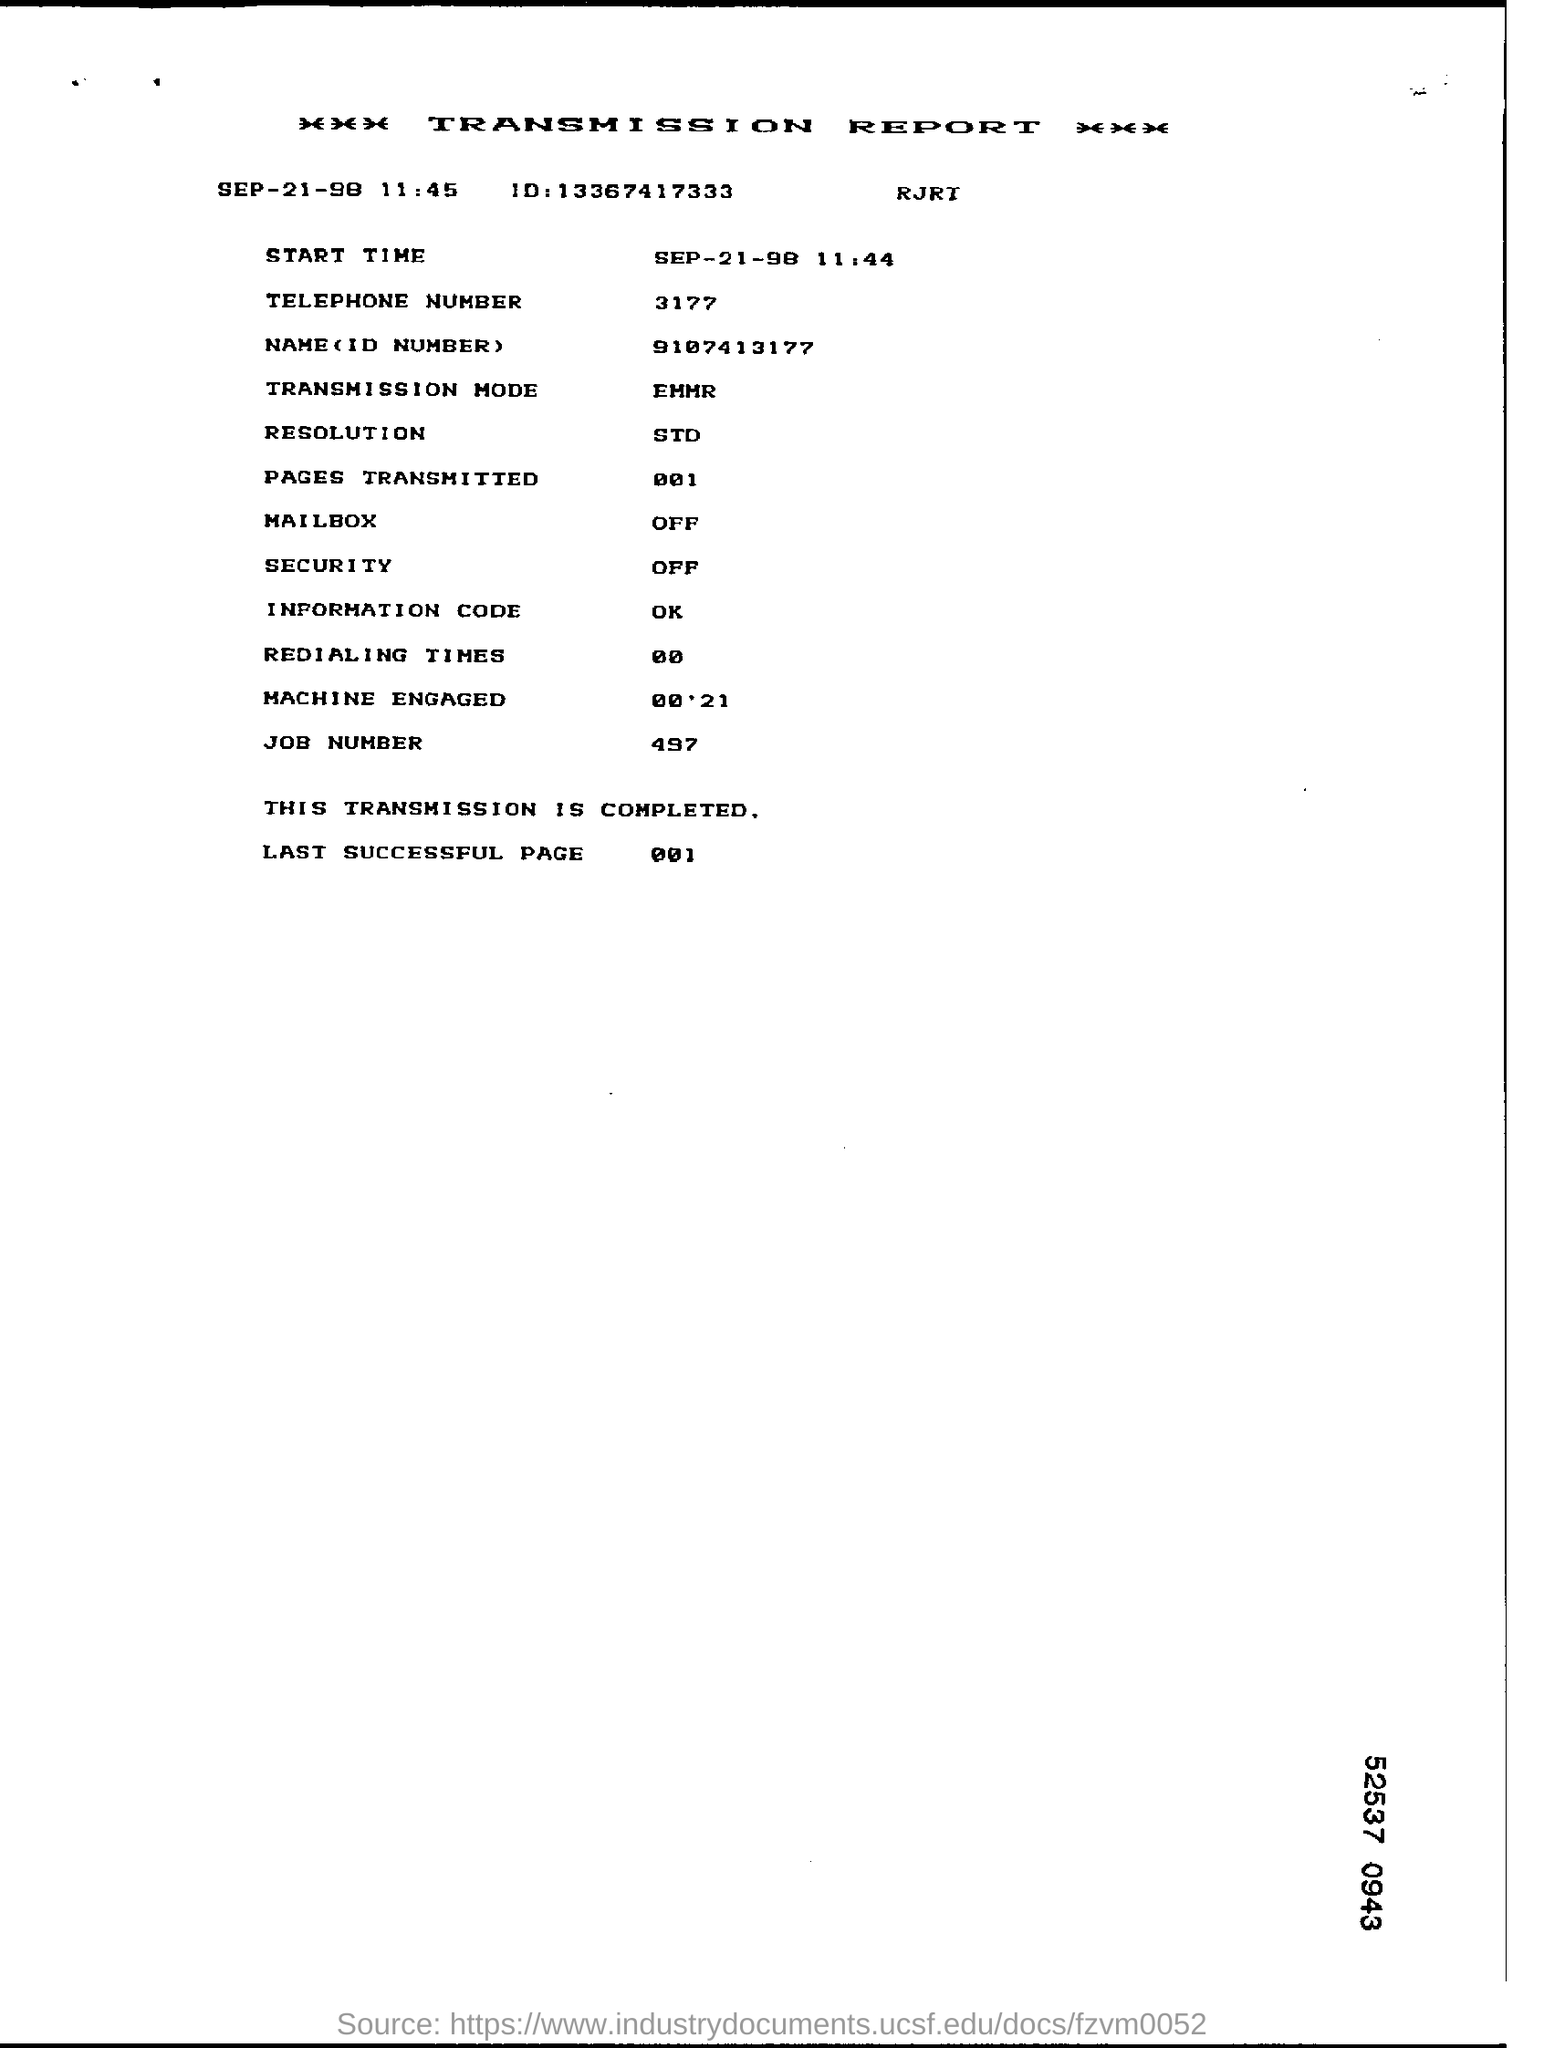What is the telephone number given in the report
Your answer should be compact. 3177. What is the last successful page number as per report
Your response must be concise. 001. What sort of number is 497
Provide a succinct answer. Job number. Heading of the document
Provide a succinct answer. TRANSMISSION REPORT. 